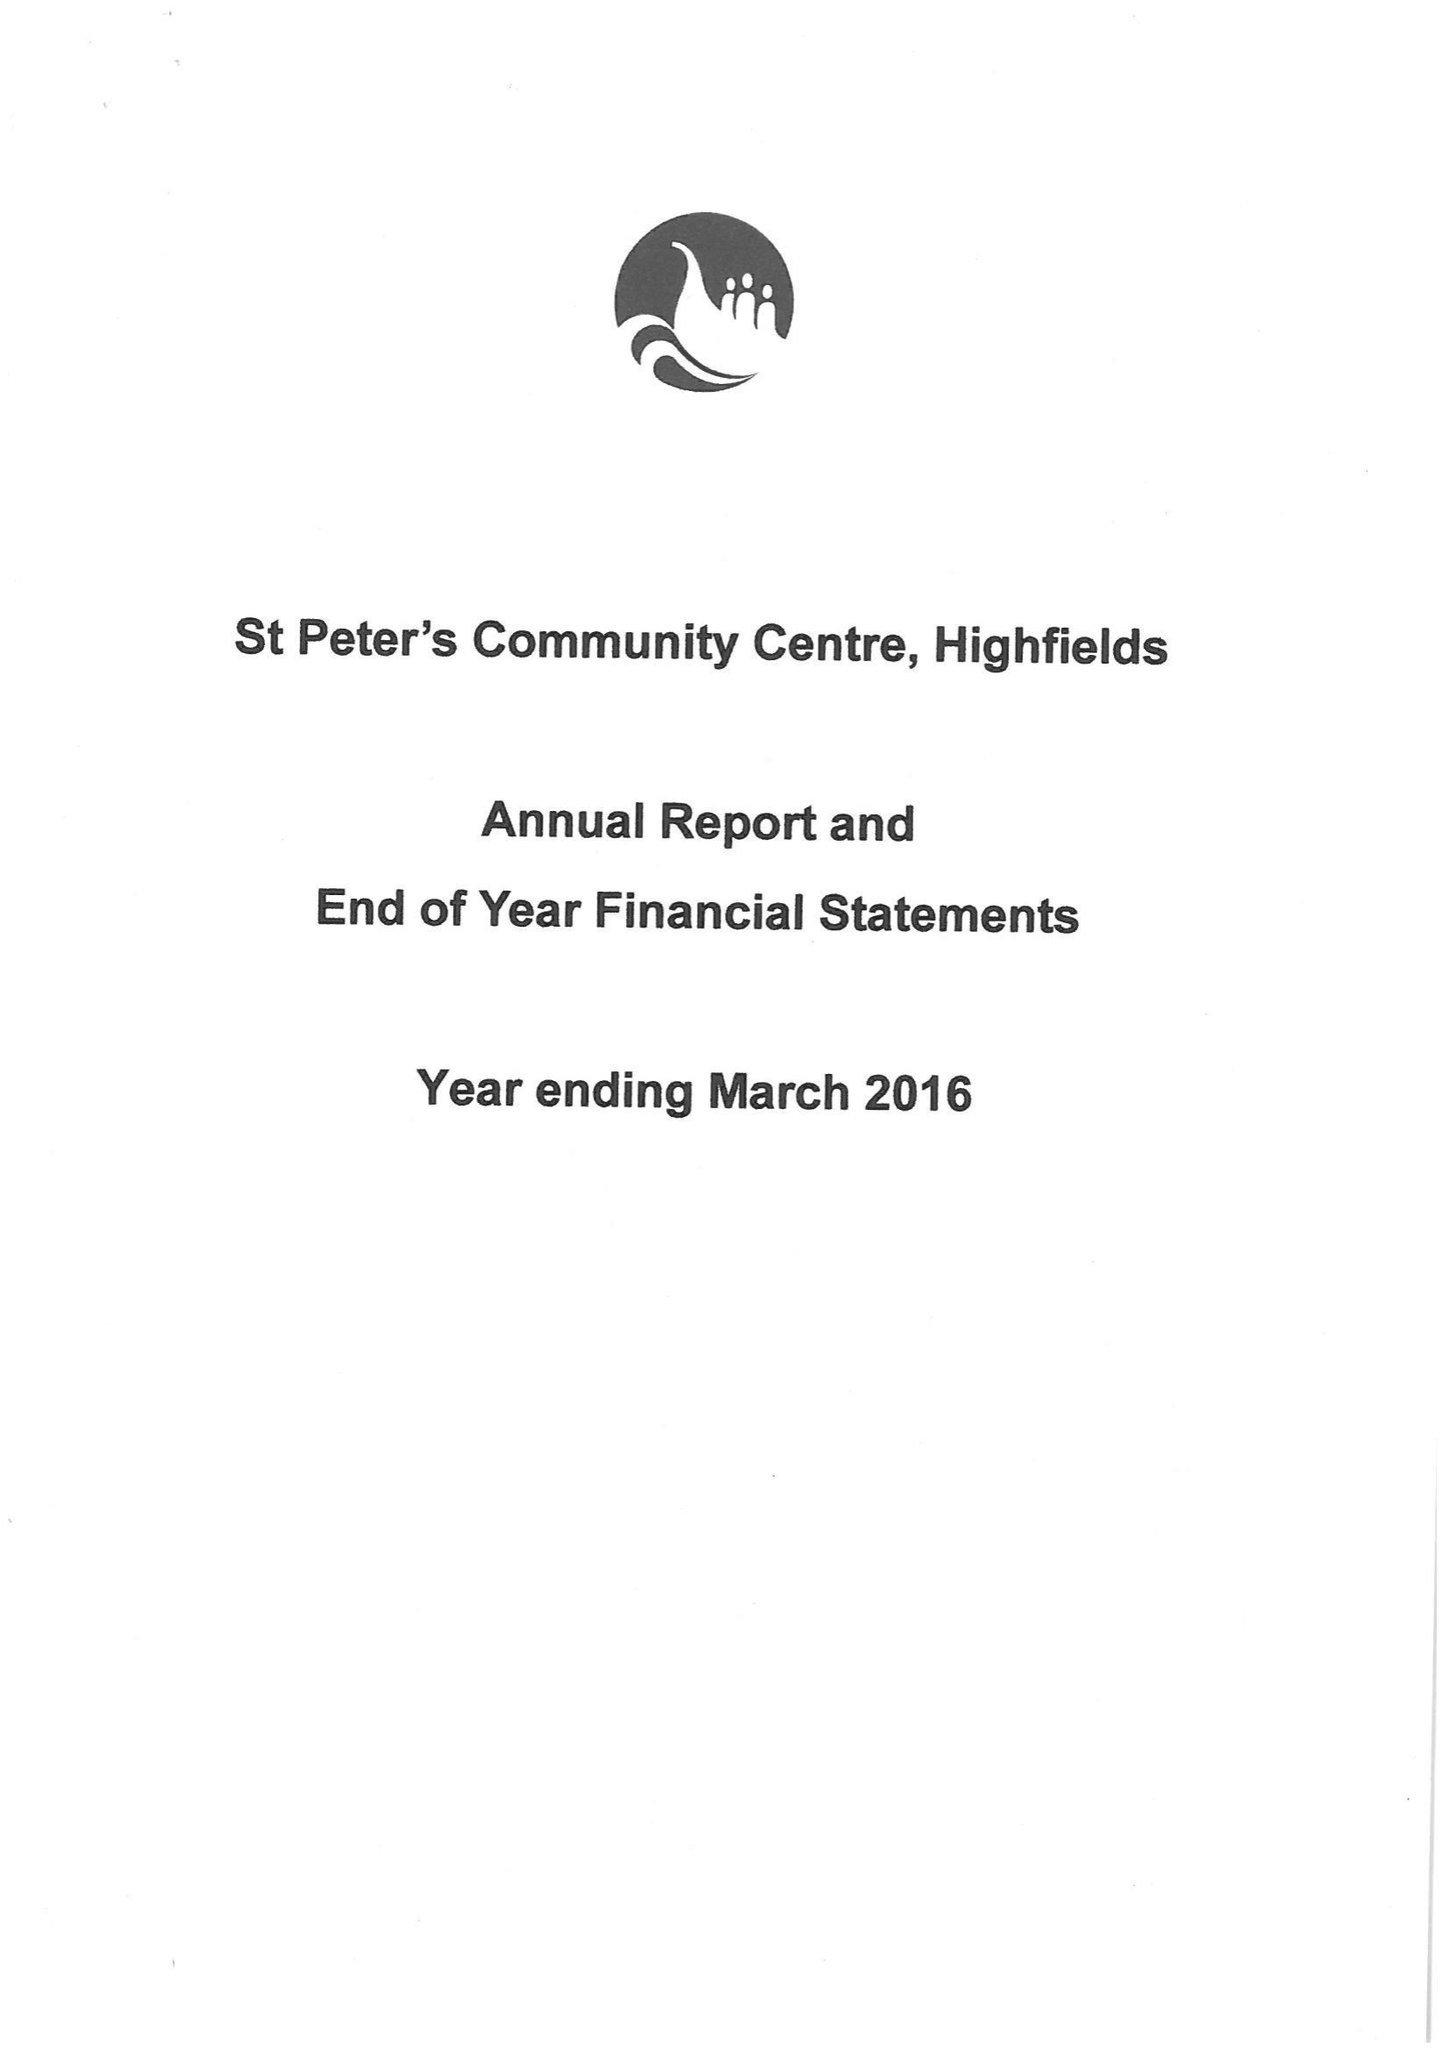What is the value for the charity_number?
Answer the question using a single word or phrase. 1038498 